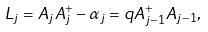<formula> <loc_0><loc_0><loc_500><loc_500>L _ { j } = A _ { j } A _ { j } ^ { + } - \alpha _ { j } = q A _ { j - 1 } ^ { + } A _ { j - 1 } ,</formula> 